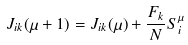Convert formula to latex. <formula><loc_0><loc_0><loc_500><loc_500>J _ { i k } ( \mu + 1 ) = J _ { i k } ( \mu ) + \frac { F _ { k } } N S _ { i } ^ { \mu }</formula> 